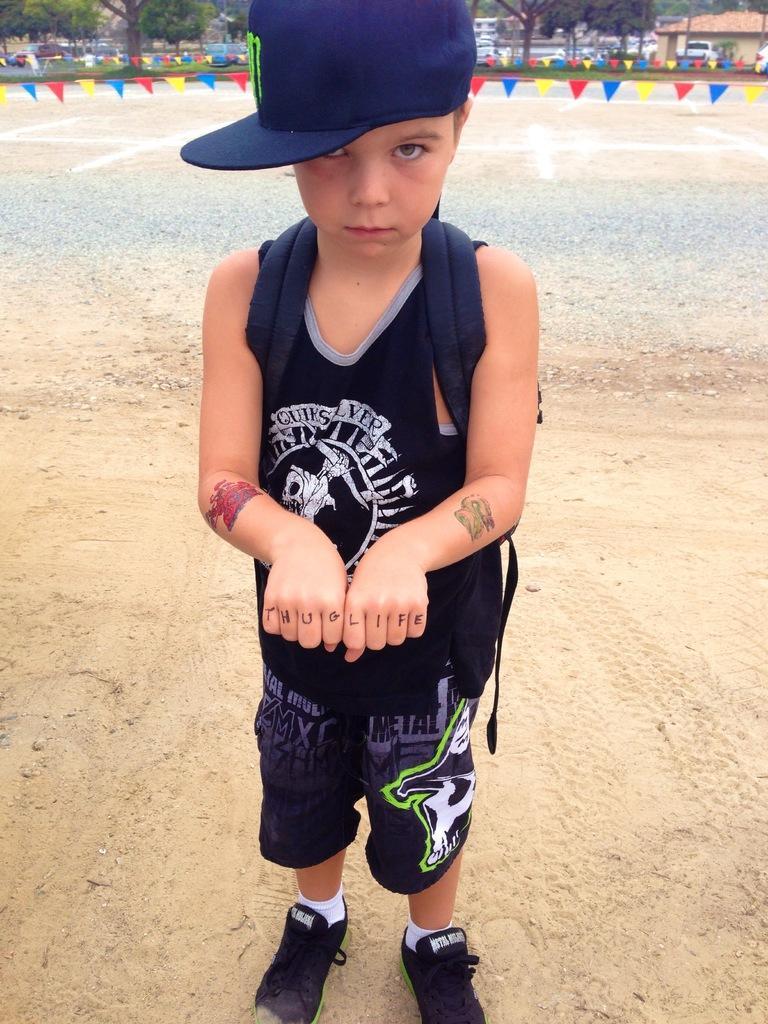In one or two sentences, can you explain what this image depicts? Here we can see a boy and he wore a cap. In the background we can see flags, vehicles, houses, and trees. 